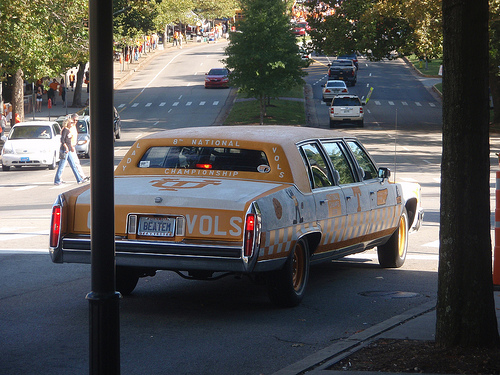<image>
Is the car behind the car? Yes. From this viewpoint, the car is positioned behind the car, with the car partially or fully occluding the car. Is there a car behind the man? No. The car is not behind the man. From this viewpoint, the car appears to be positioned elsewhere in the scene. 